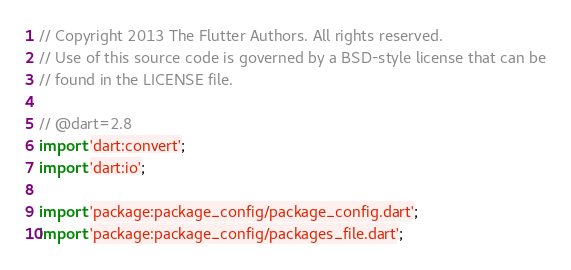Convert code to text. <code><loc_0><loc_0><loc_500><loc_500><_Dart_>// Copyright 2013 The Flutter Authors. All rights reserved.
// Use of this source code is governed by a BSD-style license that can be
// found in the LICENSE file.

// @dart=2.8
import 'dart:convert';
import 'dart:io';

import 'package:package_config/package_config.dart';
import 'package:package_config/packages_file.dart';</code> 